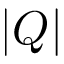Convert formula to latex. <formula><loc_0><loc_0><loc_500><loc_500>| Q |</formula> 